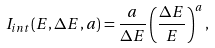Convert formula to latex. <formula><loc_0><loc_0><loc_500><loc_500>I _ { i n t } ( E , \Delta E , a ) = \frac { a } { \Delta E } \left ( \frac { \Delta E } { E } \right ) ^ { a } ,</formula> 